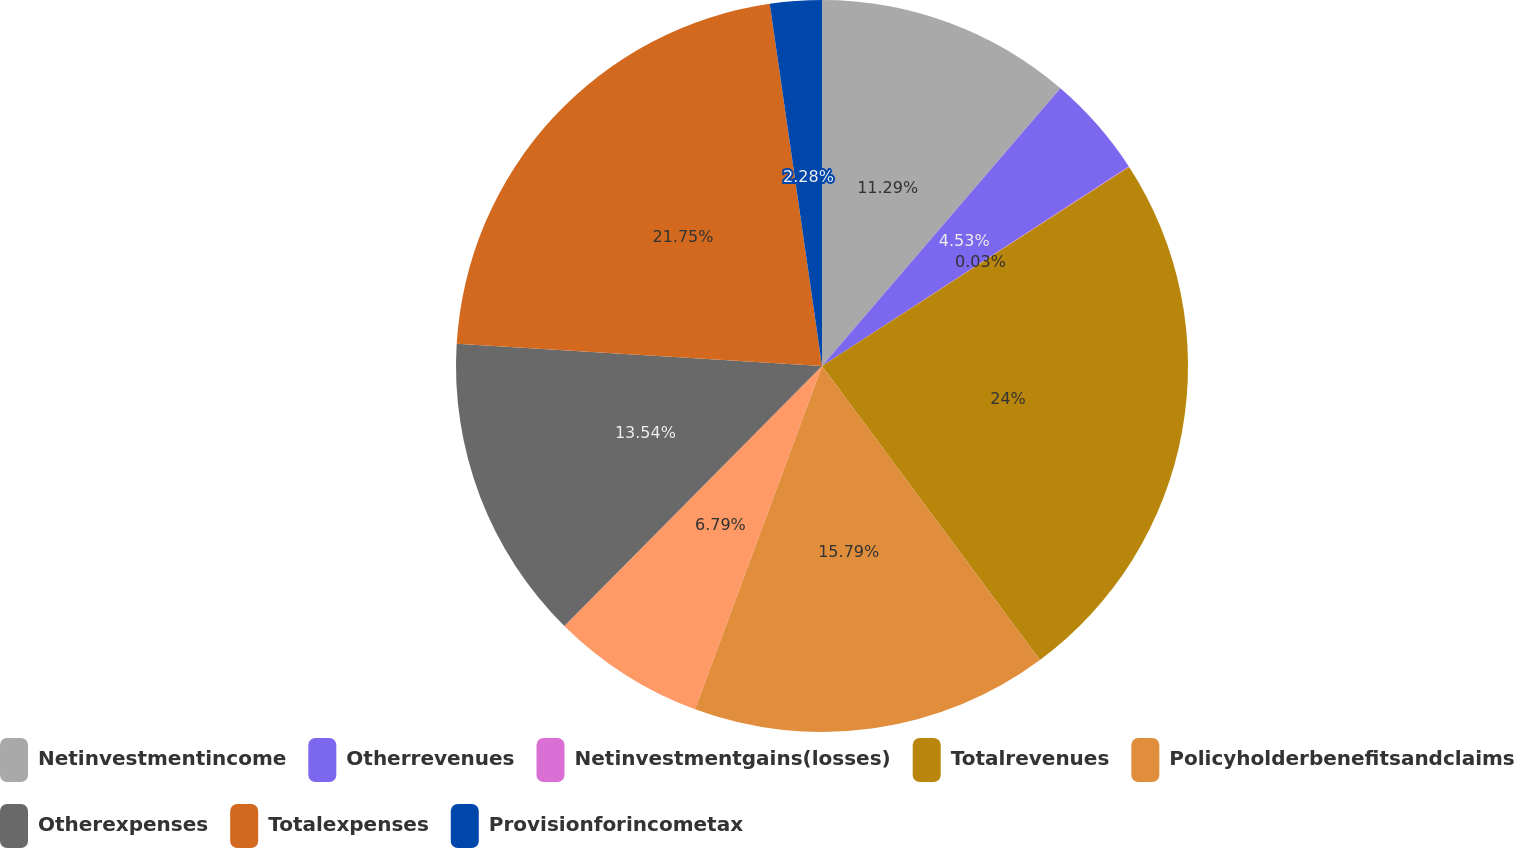Convert chart to OTSL. <chart><loc_0><loc_0><loc_500><loc_500><pie_chart><fcel>Netinvestmentincome<fcel>Otherrevenues<fcel>Netinvestmentgains(losses)<fcel>Totalrevenues<fcel>Policyholderbenefitsandclaims<fcel>Unnamed: 5<fcel>Otherexpenses<fcel>Totalexpenses<fcel>Provisionforincometax<nl><fcel>11.29%<fcel>4.53%<fcel>0.03%<fcel>24.0%<fcel>15.79%<fcel>6.79%<fcel>13.54%<fcel>21.75%<fcel>2.28%<nl></chart> 